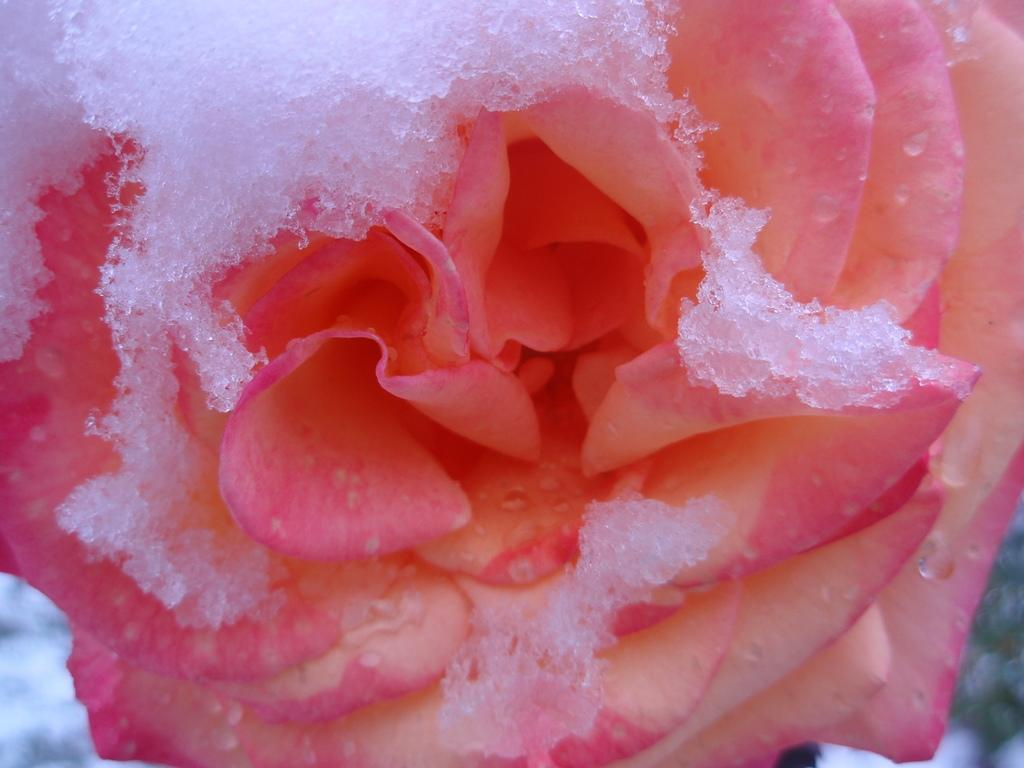What type of flower is present in the image? There is a pink color rose flower in the image. What is the weather condition in the image? There is snow in the image, suggesting a cold and wintry environment. What type of dress is the rose flower wearing in the image? Rose flowers do not wear dresses, as they are plants and not human beings. 